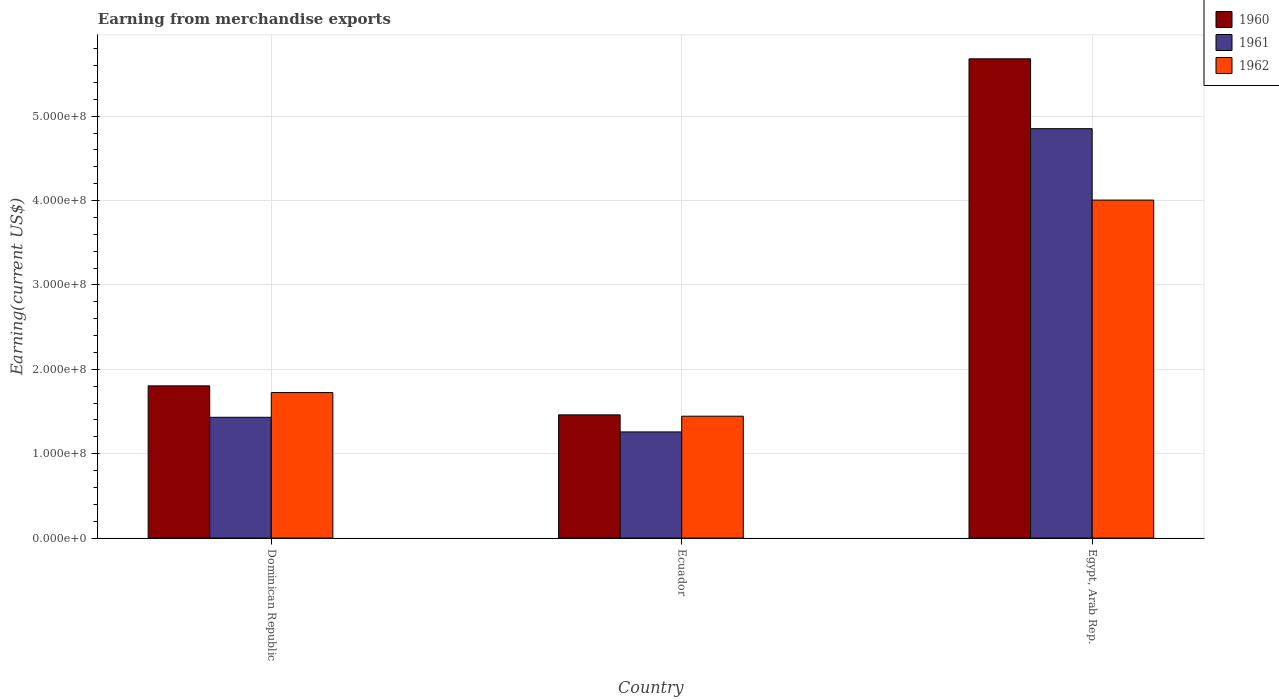Are the number of bars on each tick of the X-axis equal?
Make the answer very short. Yes. How many bars are there on the 1st tick from the left?
Ensure brevity in your answer.  3. What is the label of the 1st group of bars from the left?
Give a very brief answer. Dominican Republic. What is the amount earned from merchandise exports in 1962 in Ecuador?
Give a very brief answer. 1.44e+08. Across all countries, what is the maximum amount earned from merchandise exports in 1961?
Your answer should be compact. 4.85e+08. Across all countries, what is the minimum amount earned from merchandise exports in 1960?
Your response must be concise. 1.46e+08. In which country was the amount earned from merchandise exports in 1962 maximum?
Keep it short and to the point. Egypt, Arab Rep. In which country was the amount earned from merchandise exports in 1961 minimum?
Your response must be concise. Ecuador. What is the total amount earned from merchandise exports in 1962 in the graph?
Provide a short and direct response. 7.17e+08. What is the difference between the amount earned from merchandise exports in 1960 in Dominican Republic and that in Ecuador?
Your answer should be very brief. 3.44e+07. What is the difference between the amount earned from merchandise exports in 1962 in Egypt, Arab Rep. and the amount earned from merchandise exports in 1960 in Ecuador?
Keep it short and to the point. 2.54e+08. What is the average amount earned from merchandise exports in 1961 per country?
Your answer should be compact. 2.51e+08. What is the difference between the amount earned from merchandise exports of/in 1961 and amount earned from merchandise exports of/in 1962 in Dominican Republic?
Ensure brevity in your answer.  -2.93e+07. What is the ratio of the amount earned from merchandise exports in 1961 in Ecuador to that in Egypt, Arab Rep.?
Ensure brevity in your answer.  0.26. Is the amount earned from merchandise exports in 1960 in Ecuador less than that in Egypt, Arab Rep.?
Provide a short and direct response. Yes. What is the difference between the highest and the second highest amount earned from merchandise exports in 1962?
Your answer should be very brief. 2.56e+08. What is the difference between the highest and the lowest amount earned from merchandise exports in 1960?
Offer a very short reply. 4.22e+08. Is it the case that in every country, the sum of the amount earned from merchandise exports in 1961 and amount earned from merchandise exports in 1962 is greater than the amount earned from merchandise exports in 1960?
Give a very brief answer. Yes. How many countries are there in the graph?
Offer a terse response. 3. Are the values on the major ticks of Y-axis written in scientific E-notation?
Your answer should be compact. Yes. Does the graph contain any zero values?
Your answer should be very brief. No. Does the graph contain grids?
Keep it short and to the point. Yes. How many legend labels are there?
Give a very brief answer. 3. How are the legend labels stacked?
Keep it short and to the point. Vertical. What is the title of the graph?
Keep it short and to the point. Earning from merchandise exports. Does "2015" appear as one of the legend labels in the graph?
Your response must be concise. No. What is the label or title of the X-axis?
Your response must be concise. Country. What is the label or title of the Y-axis?
Your response must be concise. Earning(current US$). What is the Earning(current US$) of 1960 in Dominican Republic?
Provide a short and direct response. 1.80e+08. What is the Earning(current US$) of 1961 in Dominican Republic?
Your answer should be very brief. 1.43e+08. What is the Earning(current US$) of 1962 in Dominican Republic?
Provide a succinct answer. 1.72e+08. What is the Earning(current US$) in 1960 in Ecuador?
Provide a succinct answer. 1.46e+08. What is the Earning(current US$) in 1961 in Ecuador?
Provide a short and direct response. 1.26e+08. What is the Earning(current US$) in 1962 in Ecuador?
Give a very brief answer. 1.44e+08. What is the Earning(current US$) of 1960 in Egypt, Arab Rep.?
Your answer should be very brief. 5.68e+08. What is the Earning(current US$) in 1961 in Egypt, Arab Rep.?
Provide a succinct answer. 4.85e+08. What is the Earning(current US$) of 1962 in Egypt, Arab Rep.?
Offer a terse response. 4.01e+08. Across all countries, what is the maximum Earning(current US$) in 1960?
Offer a terse response. 5.68e+08. Across all countries, what is the maximum Earning(current US$) in 1961?
Give a very brief answer. 4.85e+08. Across all countries, what is the maximum Earning(current US$) of 1962?
Keep it short and to the point. 4.01e+08. Across all countries, what is the minimum Earning(current US$) of 1960?
Give a very brief answer. 1.46e+08. Across all countries, what is the minimum Earning(current US$) in 1961?
Offer a terse response. 1.26e+08. Across all countries, what is the minimum Earning(current US$) of 1962?
Your response must be concise. 1.44e+08. What is the total Earning(current US$) of 1960 in the graph?
Offer a very short reply. 8.94e+08. What is the total Earning(current US$) in 1961 in the graph?
Offer a terse response. 7.54e+08. What is the total Earning(current US$) of 1962 in the graph?
Provide a succinct answer. 7.17e+08. What is the difference between the Earning(current US$) in 1960 in Dominican Republic and that in Ecuador?
Provide a succinct answer. 3.44e+07. What is the difference between the Earning(current US$) of 1961 in Dominican Republic and that in Ecuador?
Your response must be concise. 1.73e+07. What is the difference between the Earning(current US$) in 1962 in Dominican Republic and that in Ecuador?
Your response must be concise. 2.80e+07. What is the difference between the Earning(current US$) of 1960 in Dominican Republic and that in Egypt, Arab Rep.?
Give a very brief answer. -3.88e+08. What is the difference between the Earning(current US$) of 1961 in Dominican Republic and that in Egypt, Arab Rep.?
Provide a short and direct response. -3.42e+08. What is the difference between the Earning(current US$) in 1962 in Dominican Republic and that in Egypt, Arab Rep.?
Provide a succinct answer. -2.28e+08. What is the difference between the Earning(current US$) of 1960 in Ecuador and that in Egypt, Arab Rep.?
Keep it short and to the point. -4.22e+08. What is the difference between the Earning(current US$) in 1961 in Ecuador and that in Egypt, Arab Rep.?
Your answer should be compact. -3.59e+08. What is the difference between the Earning(current US$) of 1962 in Ecuador and that in Egypt, Arab Rep.?
Make the answer very short. -2.56e+08. What is the difference between the Earning(current US$) of 1960 in Dominican Republic and the Earning(current US$) of 1961 in Ecuador?
Make the answer very short. 5.46e+07. What is the difference between the Earning(current US$) of 1960 in Dominican Republic and the Earning(current US$) of 1962 in Ecuador?
Keep it short and to the point. 3.59e+07. What is the difference between the Earning(current US$) of 1961 in Dominican Republic and the Earning(current US$) of 1962 in Ecuador?
Give a very brief answer. -1.29e+06. What is the difference between the Earning(current US$) of 1960 in Dominican Republic and the Earning(current US$) of 1961 in Egypt, Arab Rep.?
Offer a terse response. -3.05e+08. What is the difference between the Earning(current US$) of 1960 in Dominican Republic and the Earning(current US$) of 1962 in Egypt, Arab Rep.?
Your response must be concise. -2.20e+08. What is the difference between the Earning(current US$) of 1961 in Dominican Republic and the Earning(current US$) of 1962 in Egypt, Arab Rep.?
Ensure brevity in your answer.  -2.57e+08. What is the difference between the Earning(current US$) of 1960 in Ecuador and the Earning(current US$) of 1961 in Egypt, Arab Rep.?
Make the answer very short. -3.39e+08. What is the difference between the Earning(current US$) of 1960 in Ecuador and the Earning(current US$) of 1962 in Egypt, Arab Rep.?
Provide a short and direct response. -2.54e+08. What is the difference between the Earning(current US$) of 1961 in Ecuador and the Earning(current US$) of 1962 in Egypt, Arab Rep.?
Provide a short and direct response. -2.75e+08. What is the average Earning(current US$) of 1960 per country?
Provide a short and direct response. 2.98e+08. What is the average Earning(current US$) in 1961 per country?
Make the answer very short. 2.51e+08. What is the average Earning(current US$) in 1962 per country?
Ensure brevity in your answer.  2.39e+08. What is the difference between the Earning(current US$) in 1960 and Earning(current US$) in 1961 in Dominican Republic?
Your response must be concise. 3.72e+07. What is the difference between the Earning(current US$) of 1960 and Earning(current US$) of 1962 in Dominican Republic?
Your answer should be very brief. 7.94e+06. What is the difference between the Earning(current US$) of 1961 and Earning(current US$) of 1962 in Dominican Republic?
Ensure brevity in your answer.  -2.93e+07. What is the difference between the Earning(current US$) in 1960 and Earning(current US$) in 1961 in Ecuador?
Offer a terse response. 2.02e+07. What is the difference between the Earning(current US$) in 1960 and Earning(current US$) in 1962 in Ecuador?
Offer a terse response. 1.58e+06. What is the difference between the Earning(current US$) of 1961 and Earning(current US$) of 1962 in Ecuador?
Ensure brevity in your answer.  -1.86e+07. What is the difference between the Earning(current US$) in 1960 and Earning(current US$) in 1961 in Egypt, Arab Rep.?
Your response must be concise. 8.28e+07. What is the difference between the Earning(current US$) in 1960 and Earning(current US$) in 1962 in Egypt, Arab Rep.?
Make the answer very short. 1.67e+08. What is the difference between the Earning(current US$) of 1961 and Earning(current US$) of 1962 in Egypt, Arab Rep.?
Your response must be concise. 8.46e+07. What is the ratio of the Earning(current US$) of 1960 in Dominican Republic to that in Ecuador?
Keep it short and to the point. 1.24. What is the ratio of the Earning(current US$) in 1961 in Dominican Republic to that in Ecuador?
Provide a short and direct response. 1.14. What is the ratio of the Earning(current US$) of 1962 in Dominican Republic to that in Ecuador?
Offer a very short reply. 1.19. What is the ratio of the Earning(current US$) of 1960 in Dominican Republic to that in Egypt, Arab Rep.?
Your answer should be very brief. 0.32. What is the ratio of the Earning(current US$) of 1961 in Dominican Republic to that in Egypt, Arab Rep.?
Ensure brevity in your answer.  0.3. What is the ratio of the Earning(current US$) of 1962 in Dominican Republic to that in Egypt, Arab Rep.?
Ensure brevity in your answer.  0.43. What is the ratio of the Earning(current US$) in 1960 in Ecuador to that in Egypt, Arab Rep.?
Offer a very short reply. 0.26. What is the ratio of the Earning(current US$) in 1961 in Ecuador to that in Egypt, Arab Rep.?
Your answer should be very brief. 0.26. What is the ratio of the Earning(current US$) in 1962 in Ecuador to that in Egypt, Arab Rep.?
Your answer should be compact. 0.36. What is the difference between the highest and the second highest Earning(current US$) of 1960?
Keep it short and to the point. 3.88e+08. What is the difference between the highest and the second highest Earning(current US$) in 1961?
Provide a short and direct response. 3.42e+08. What is the difference between the highest and the second highest Earning(current US$) of 1962?
Make the answer very short. 2.28e+08. What is the difference between the highest and the lowest Earning(current US$) in 1960?
Your answer should be compact. 4.22e+08. What is the difference between the highest and the lowest Earning(current US$) in 1961?
Provide a short and direct response. 3.59e+08. What is the difference between the highest and the lowest Earning(current US$) of 1962?
Offer a very short reply. 2.56e+08. 